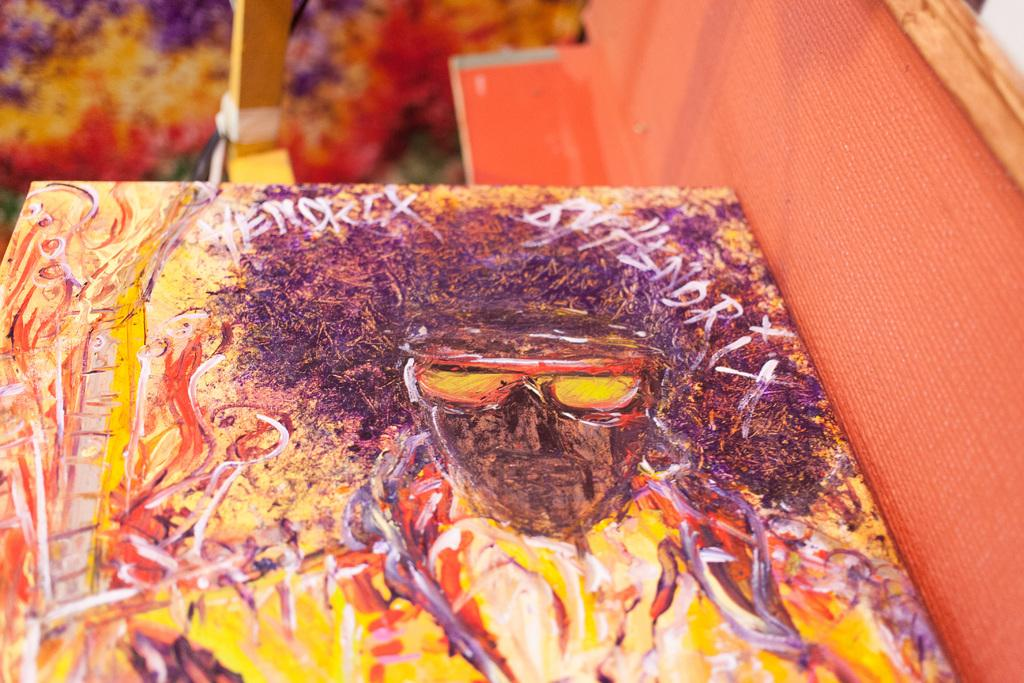What is depicted on the board in the image? There is a painting on a board in the image. What color is the wall on the right side of the image? The wall on the right side of the image is orange. How would you describe the background of the image? The background of the image is blurred. What type of knife is being used to carve the marble chicken in the image? There is no knife, marble, or chicken present in the image. 